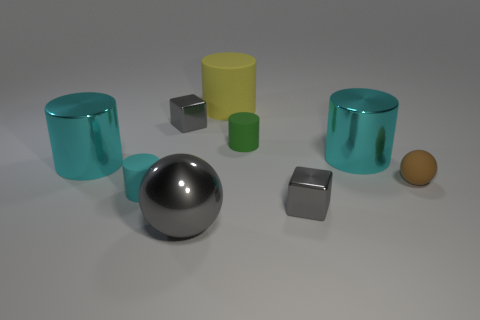What shape is the big object in front of the big cyan shiny cylinder that is on the left side of the gray cube that is behind the matte sphere?
Offer a very short reply. Sphere. The cyan thing that is the same material as the small brown object is what size?
Give a very brief answer. Small. Are there more tiny blue metallic spheres than small green things?
Make the answer very short. No. What material is the cyan thing that is the same size as the brown thing?
Offer a terse response. Rubber. There is a matte cylinder that is in front of the green matte thing; does it have the same size as the large yellow object?
Your answer should be very brief. No. What number of blocks are either metallic things or large gray objects?
Keep it short and to the point. 2. What is the material of the gray block behind the small cyan matte object?
Make the answer very short. Metal. Are there fewer big rubber objects than big brown rubber blocks?
Give a very brief answer. No. What size is the cylinder that is both behind the tiny brown rubber object and left of the yellow matte object?
Make the answer very short. Large. What is the size of the cyan metal object on the left side of the tiny cylinder that is right of the ball left of the tiny green cylinder?
Provide a short and direct response. Large. 